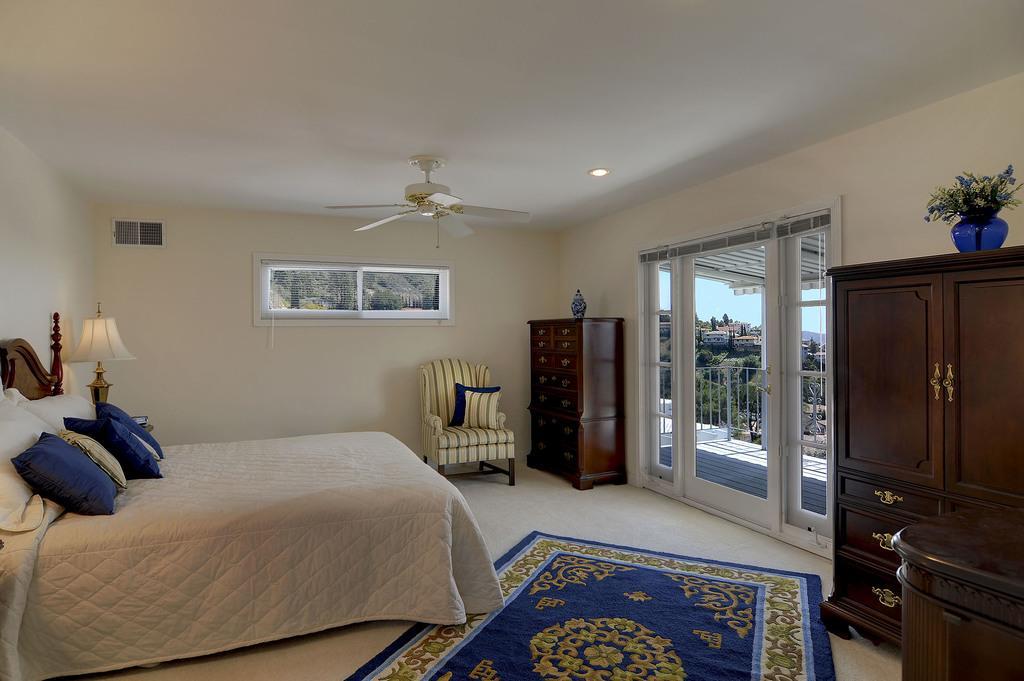Describe this image in one or two sentences. This is the image inside a room. We can see a bed with pillows, lamp, ceiling fan, chair, cupboards, flower vase and a carpet on the floor. This is the window glass through which trees and buildings are seen. 